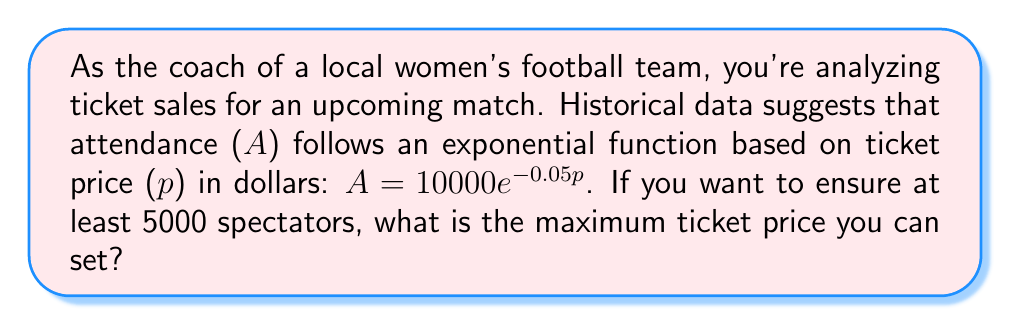Solve this math problem. Let's approach this step-by-step:

1) We're given the exponential function: $A = 10000e^{-0.05p}$
   Where A is attendance and p is the ticket price in dollars.

2) We want to find the maximum price p where A is at least 5000.
   So, we can set up the inequality:
   $10000e^{-0.05p} \geq 5000$

3) Divide both sides by 10000:
   $e^{-0.05p} \geq 0.5$

4) Take the natural log of both sides:
   $\ln(e^{-0.05p}) \geq \ln(0.5)$

5) Simplify the left side:
   $-0.05p \geq \ln(0.5)$

6) Divide both sides by -0.05 (and flip the inequality sign):
   $p \leq -\frac{\ln(0.5)}{0.05}$

7) Calculate:
   $p \leq -\frac{-0.69315}{0.05} \approx 13.86$

Therefore, the maximum ticket price to ensure at least 5000 spectators is approximately $13.86.
Answer: $13.86 